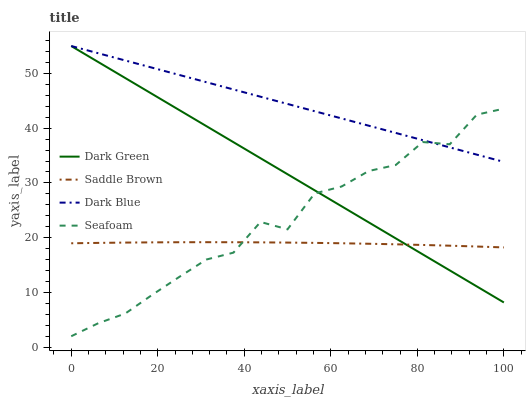Does Saddle Brown have the minimum area under the curve?
Answer yes or no. Yes. Does Dark Blue have the maximum area under the curve?
Answer yes or no. Yes. Does Seafoam have the minimum area under the curve?
Answer yes or no. No. Does Seafoam have the maximum area under the curve?
Answer yes or no. No. Is Dark Green the smoothest?
Answer yes or no. Yes. Is Seafoam the roughest?
Answer yes or no. Yes. Is Saddle Brown the smoothest?
Answer yes or no. No. Is Saddle Brown the roughest?
Answer yes or no. No. Does Saddle Brown have the lowest value?
Answer yes or no. No. Does Dark Green have the highest value?
Answer yes or no. Yes. Does Seafoam have the highest value?
Answer yes or no. No. Is Saddle Brown less than Dark Blue?
Answer yes or no. Yes. Is Dark Blue greater than Saddle Brown?
Answer yes or no. Yes. Does Dark Green intersect Dark Blue?
Answer yes or no. Yes. Is Dark Green less than Dark Blue?
Answer yes or no. No. Is Dark Green greater than Dark Blue?
Answer yes or no. No. Does Saddle Brown intersect Dark Blue?
Answer yes or no. No. 